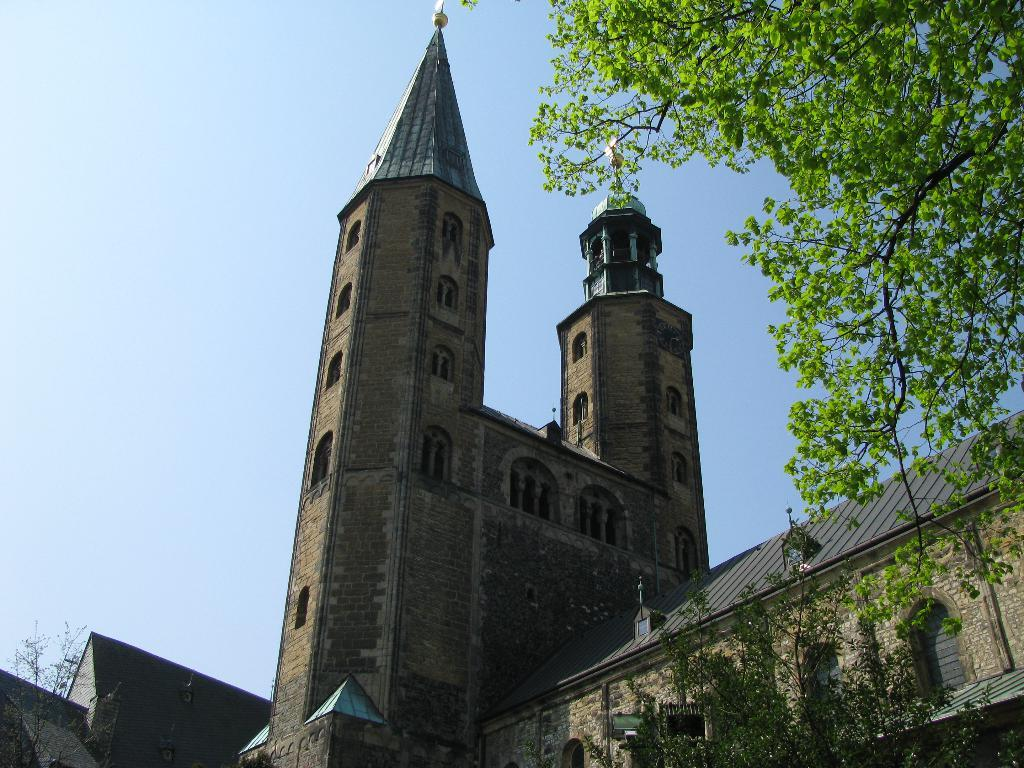What type of structures can be seen in the image? There are buildings in the image. What type of vegetation is present in the image? There are trees in the image. How does the spot on the building twist in the image? There is no spot on the building mentioned in the facts, and therefore no such twisting can be observed. 